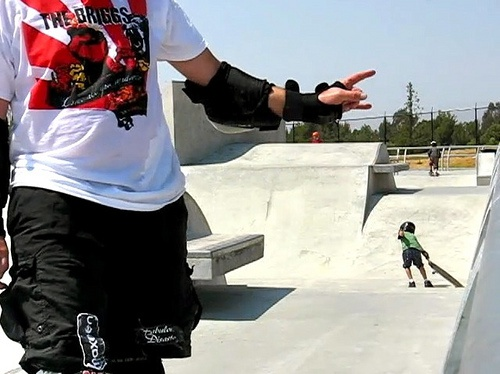Describe the objects in this image and their specific colors. I can see people in lavender, black, and darkgray tones, bench in lavender, gray, darkgray, and ivory tones, people in lavender, black, ivory, gray, and darkgray tones, people in lavender, black, gray, and darkgray tones, and skateboard in lavender, gray, black, and ivory tones in this image. 